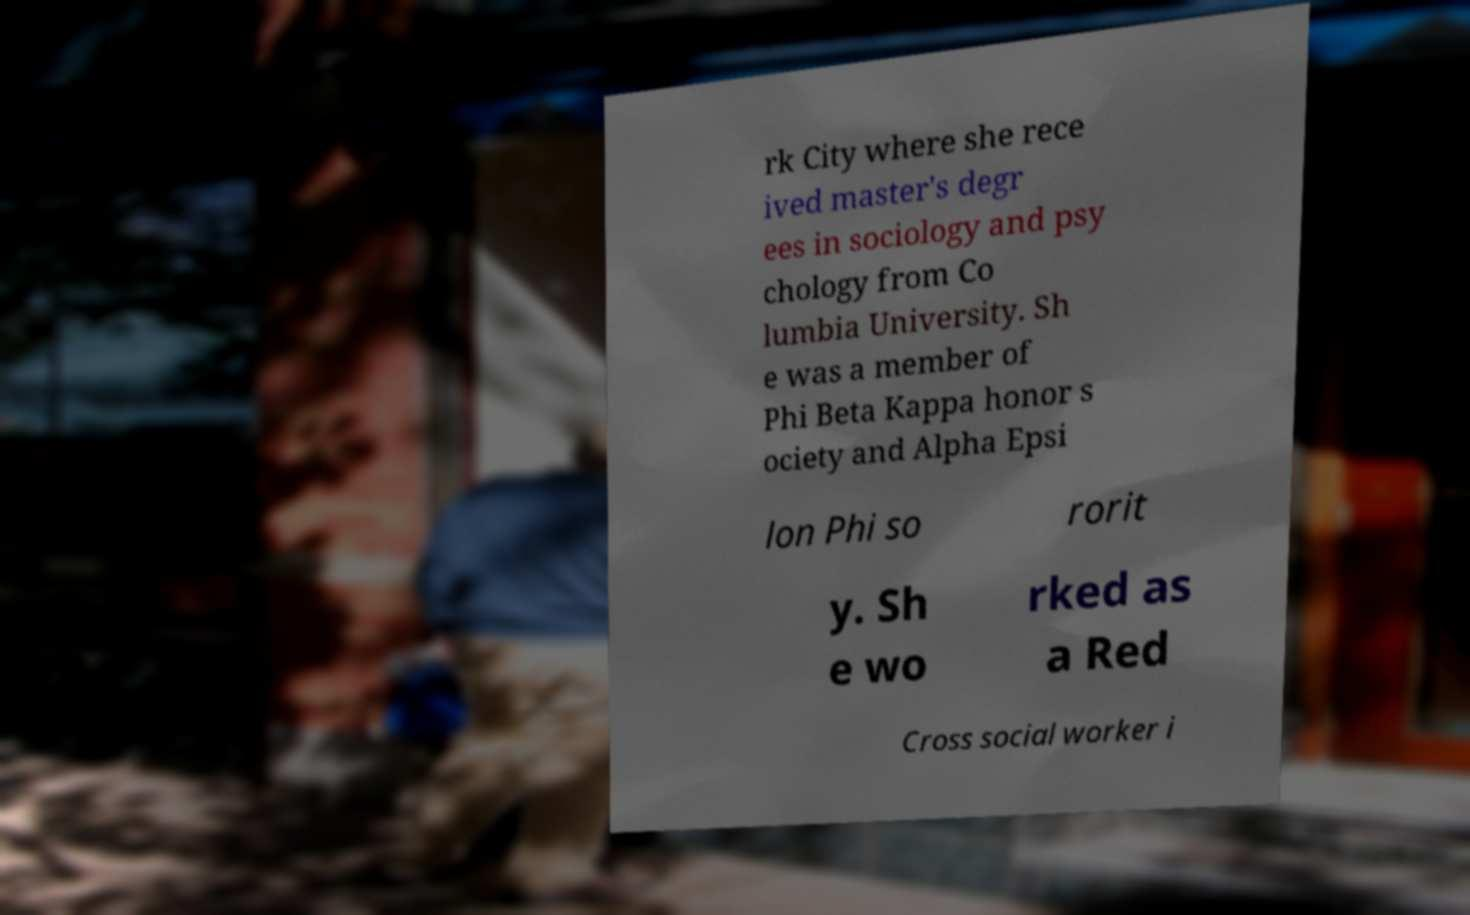I need the written content from this picture converted into text. Can you do that? rk City where she rece ived master's degr ees in sociology and psy chology from Co lumbia University. Sh e was a member of Phi Beta Kappa honor s ociety and Alpha Epsi lon Phi so rorit y. Sh e wo rked as a Red Cross social worker i 